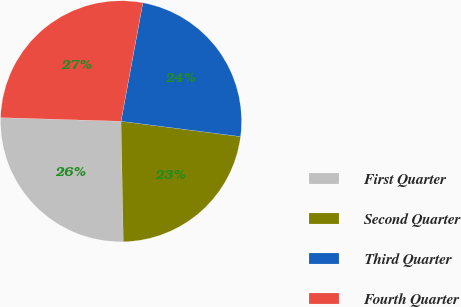Convert chart to OTSL. <chart><loc_0><loc_0><loc_500><loc_500><pie_chart><fcel>First Quarter<fcel>Second Quarter<fcel>Third Quarter<fcel>Fourth Quarter<nl><fcel>25.78%<fcel>22.67%<fcel>24.13%<fcel>27.42%<nl></chart> 